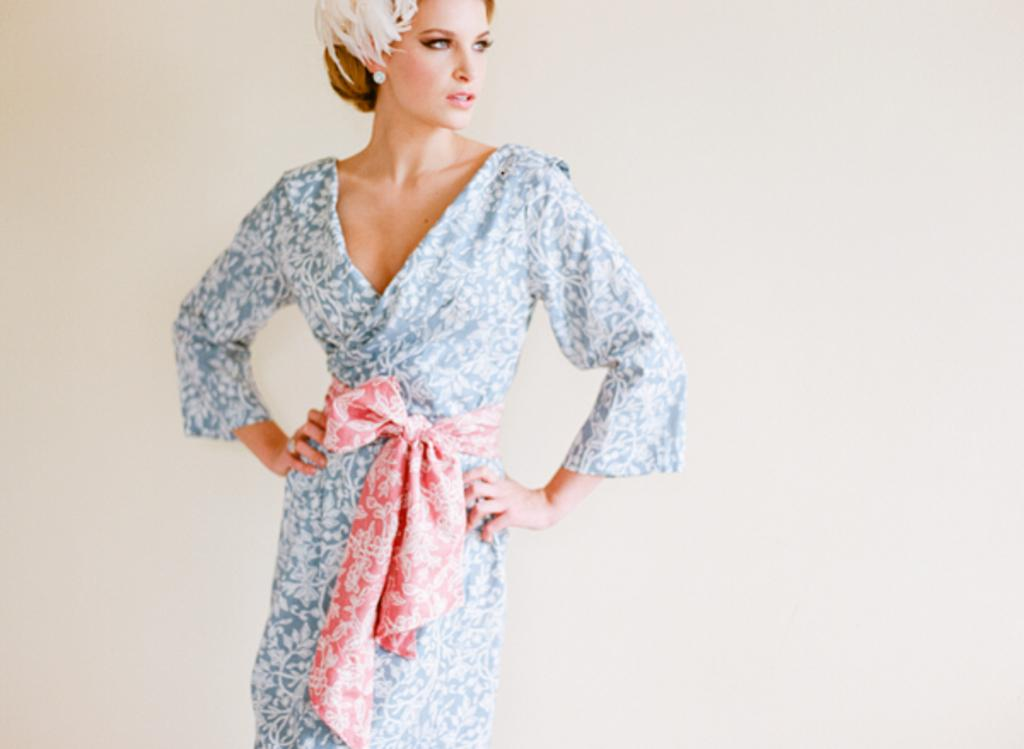What is the main subject in the image? There is a woman standing in the image. What can be seen in the background of the image? There is a wall visible in the background of the image. What type of spy equipment can be seen in the woman's hands in the image? There is no spy equipment visible in the woman's hands in the image. What type of meeting is taking place in the image? There is no meeting taking place in the image; it only features a woman standing in front of a wall. 